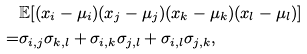Convert formula to latex. <formula><loc_0><loc_0><loc_500><loc_500>& \mathbb { E } [ ( x _ { i } - \mu _ { i } ) ( x _ { j } - \mu _ { j } ) ( x _ { k } - \mu _ { k } ) ( x _ { l } - \mu _ { l } ) ] \\ = & \sigma _ { i , j } \sigma _ { k , l } + \sigma _ { i , k } \sigma _ { j , l } + \sigma _ { i , l } \sigma _ { j , k } ,</formula> 